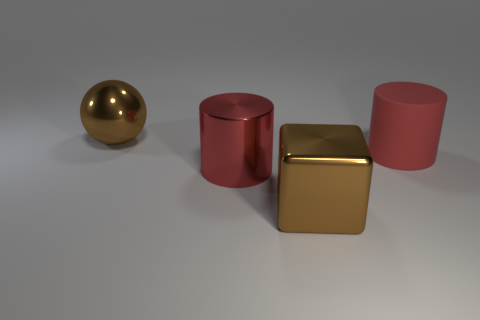Add 4 large red shiny objects. How many objects exist? 8 Subtract all balls. How many objects are left? 3 Subtract 1 cylinders. How many cylinders are left? 1 Add 3 red rubber cylinders. How many red rubber cylinders exist? 4 Subtract 0 yellow blocks. How many objects are left? 4 Subtract all purple cubes. Subtract all cyan cylinders. How many cubes are left? 1 Subtract all blue cylinders. How many green balls are left? 0 Subtract all tiny gray things. Subtract all large red matte things. How many objects are left? 3 Add 3 large rubber objects. How many large rubber objects are left? 4 